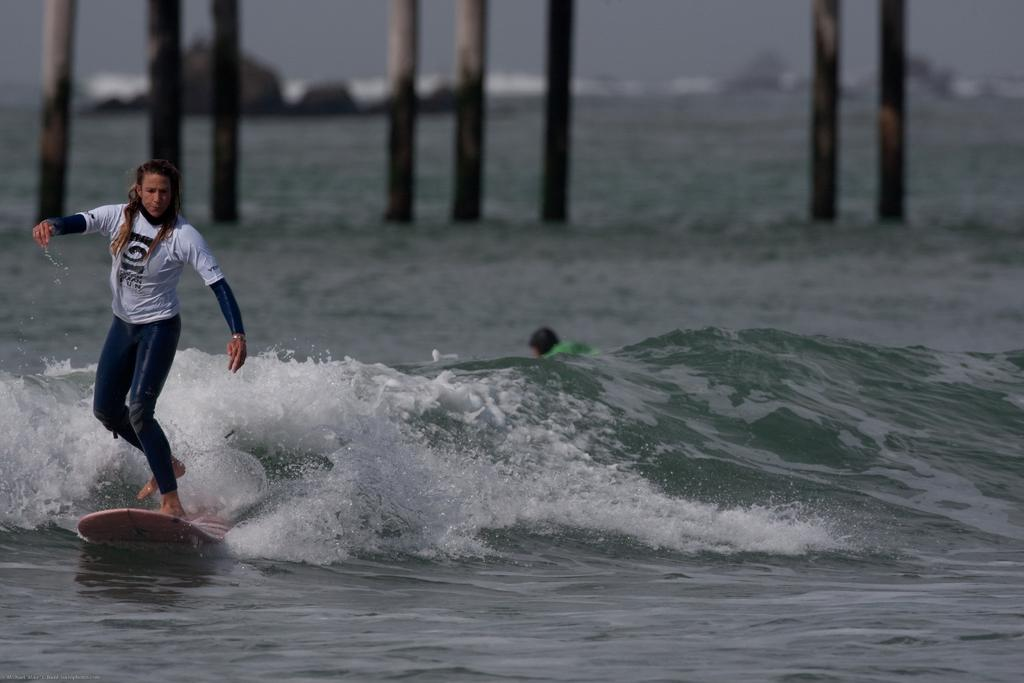Who is the main subject in the image? There is a girl in the image. What is the girl doing in the image? The girl is standing on a surfing board and surfing on a sea. What can be seen in the background of the image? There are poles in the background of the image, and the background is blurred. What type of flowers can be seen in the image? There are no flowers present in the image. Can you tell me the total cost of the items on the receipt in the image? There is no receipt present in the image. 